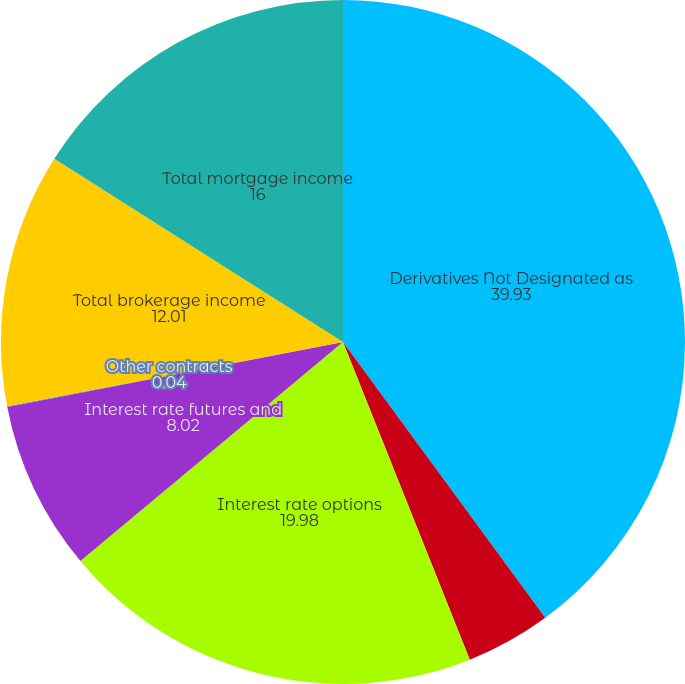Convert chart to OTSL. <chart><loc_0><loc_0><loc_500><loc_500><pie_chart><fcel>Derivatives Not Designated as<fcel>Interest rate swaps<fcel>Interest rate options<fcel>Interest rate futures and<fcel>Other contracts<fcel>Total brokerage income<fcel>Total mortgage income<nl><fcel>39.93%<fcel>4.03%<fcel>19.98%<fcel>8.02%<fcel>0.04%<fcel>12.01%<fcel>16.0%<nl></chart> 